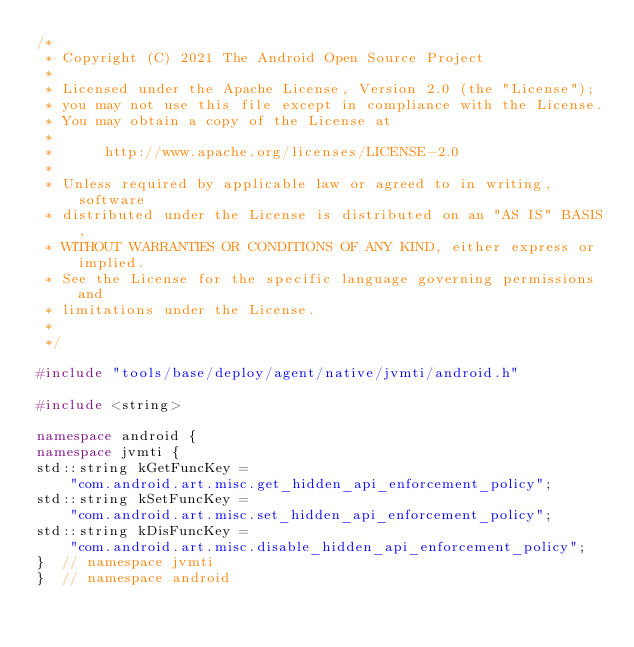<code> <loc_0><loc_0><loc_500><loc_500><_C++_>/*
 * Copyright (C) 2021 The Android Open Source Project
 *
 * Licensed under the Apache License, Version 2.0 (the "License");
 * you may not use this file except in compliance with the License.
 * You may obtain a copy of the License at
 *
 *      http://www.apache.org/licenses/LICENSE-2.0
 *
 * Unless required by applicable law or agreed to in writing, software
 * distributed under the License is distributed on an "AS IS" BASIS,
 * WITHOUT WARRANTIES OR CONDITIONS OF ANY KIND, either express or implied.
 * See the License for the specific language governing permissions and
 * limitations under the License.
 *
 */

#include "tools/base/deploy/agent/native/jvmti/android.h"

#include <string>

namespace android {
namespace jvmti {
std::string kGetFuncKey =
    "com.android.art.misc.get_hidden_api_enforcement_policy";
std::string kSetFuncKey =
    "com.android.art.misc.set_hidden_api_enforcement_policy";
std::string kDisFuncKey =
    "com.android.art.misc.disable_hidden_api_enforcement_policy";
}  // namespace jvmti
}  // namespace android
</code> 